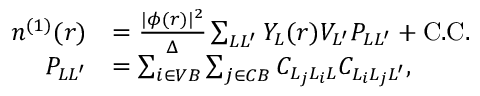Convert formula to latex. <formula><loc_0><loc_0><loc_500><loc_500>\begin{array} { r l } { n ^ { ( 1 ) } ( r ) } & { = \frac { | \phi ( r ) | ^ { 2 } } { \Delta } \sum _ { L L ^ { \prime } } Y _ { L } ( r ) V _ { L ^ { \prime } } P _ { L L ^ { \prime } } + C . C . } \\ { P _ { L L ^ { \prime } } } & { = \sum _ { i \in V B } \sum _ { j \in C B } C _ { L _ { j } L _ { i } L } C _ { L _ { i } L _ { j } L ^ { \prime } } , } \end{array}</formula> 